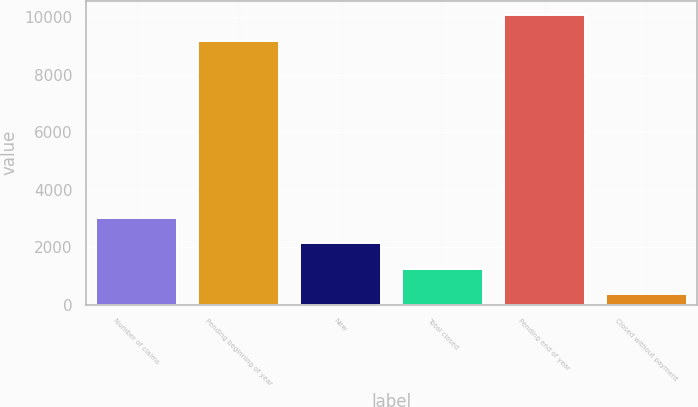Convert chart to OTSL. <chart><loc_0><loc_0><loc_500><loc_500><bar_chart><fcel>Number of claims<fcel>Pending beginning of year<fcel>New<fcel>Total closed<fcel>Pending end of year<fcel>Closed without payment<nl><fcel>3031.6<fcel>9175<fcel>2142.4<fcel>1253.2<fcel>10064.2<fcel>364<nl></chart> 